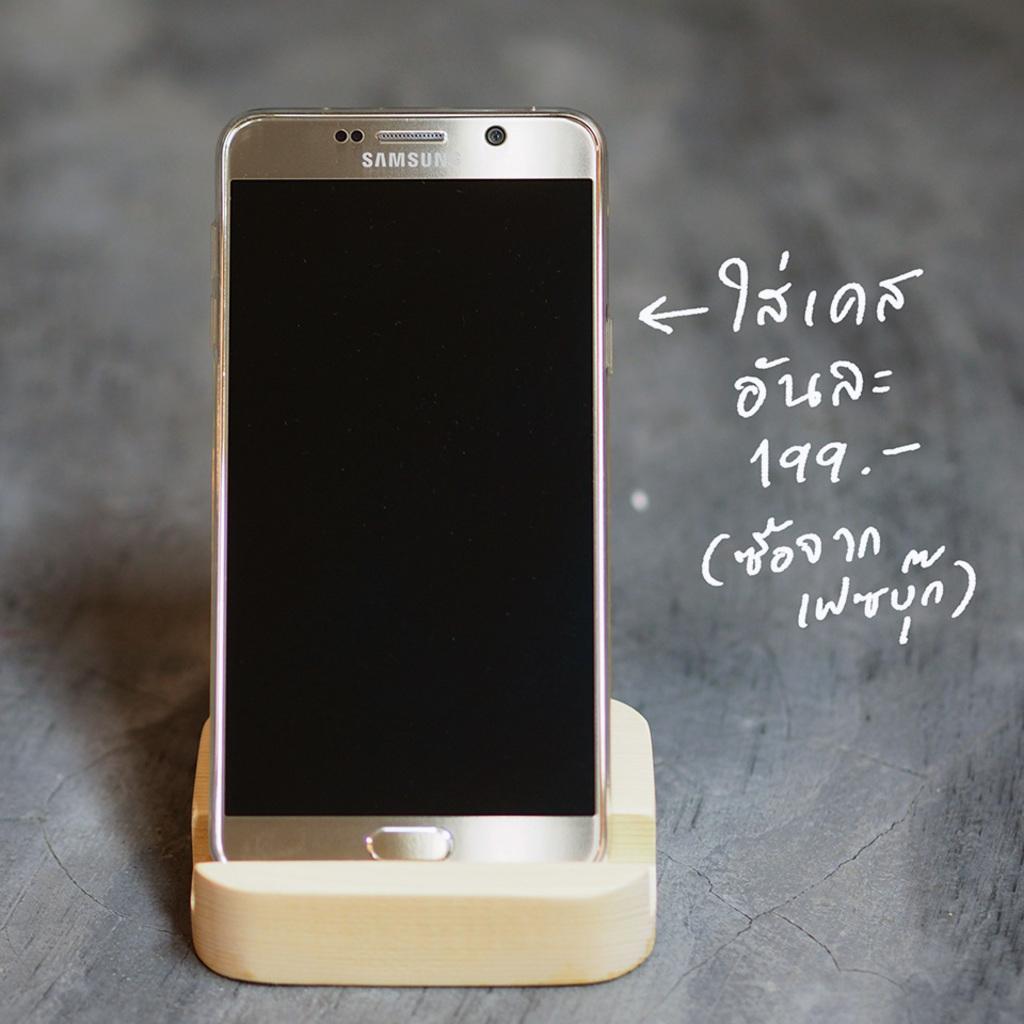What brand of phone is it?
Provide a succinct answer. Samsung. What brand is this cell phone?
Offer a terse response. Samsung. 